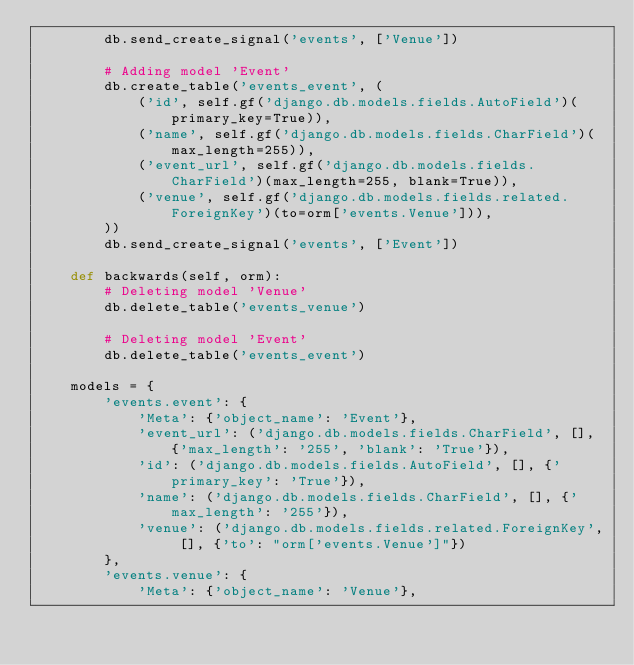<code> <loc_0><loc_0><loc_500><loc_500><_Python_>        db.send_create_signal('events', ['Venue'])

        # Adding model 'Event'
        db.create_table('events_event', (
            ('id', self.gf('django.db.models.fields.AutoField')(primary_key=True)),
            ('name', self.gf('django.db.models.fields.CharField')(max_length=255)),
            ('event_url', self.gf('django.db.models.fields.CharField')(max_length=255, blank=True)),
            ('venue', self.gf('django.db.models.fields.related.ForeignKey')(to=orm['events.Venue'])),
        ))
        db.send_create_signal('events', ['Event'])

    def backwards(self, orm):
        # Deleting model 'Venue'
        db.delete_table('events_venue')

        # Deleting model 'Event'
        db.delete_table('events_event')

    models = {
        'events.event': {
            'Meta': {'object_name': 'Event'},
            'event_url': ('django.db.models.fields.CharField', [], {'max_length': '255', 'blank': 'True'}),
            'id': ('django.db.models.fields.AutoField', [], {'primary_key': 'True'}),
            'name': ('django.db.models.fields.CharField', [], {'max_length': '255'}),
            'venue': ('django.db.models.fields.related.ForeignKey', [], {'to': "orm['events.Venue']"})
        },
        'events.venue': {
            'Meta': {'object_name': 'Venue'},</code> 